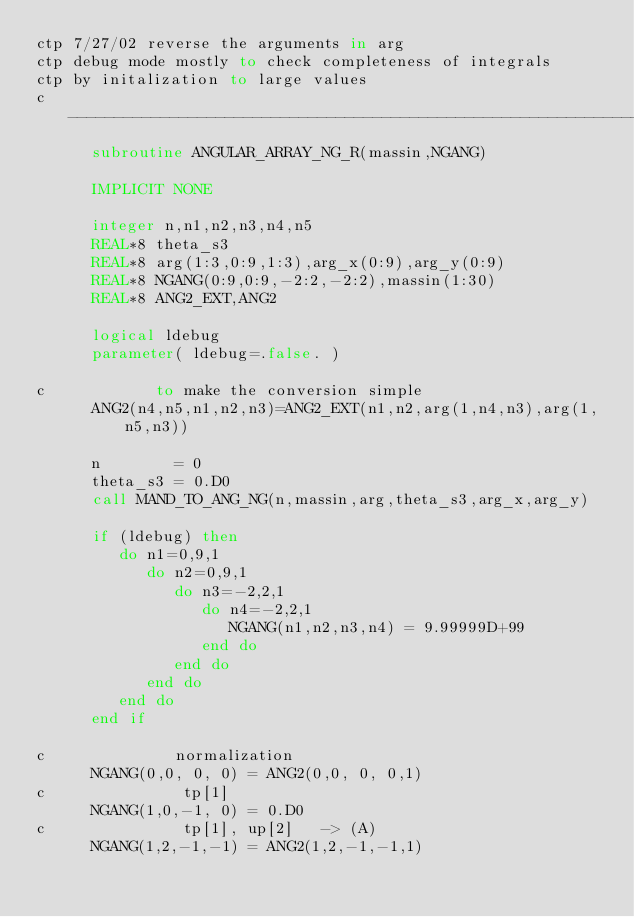<code> <loc_0><loc_0><loc_500><loc_500><_FORTRAN_>ctp 7/27/02 reverse the arguments in arg
ctp debug mode mostly to check completeness of integrals 
ctp by initalization to large values 
c ----------------------------------------------------------------------
      subroutine ANGULAR_ARRAY_NG_R(massin,NGANG)

      IMPLICIT NONE

      integer n,n1,n2,n3,n4,n5
      REAL*8 theta_s3
      REAL*8 arg(1:3,0:9,1:3),arg_x(0:9),arg_y(0:9)
      REAL*8 NGANG(0:9,0:9,-2:2,-2:2),massin(1:30)
      REAL*8 ANG2_EXT,ANG2

      logical ldebug 
      parameter( ldebug=.false. )
           
c            to make the conversion simple  
      ANG2(n4,n5,n1,n2,n3)=ANG2_EXT(n1,n2,arg(1,n4,n3),arg(1,n5,n3))
     
      n        = 0
      theta_s3 = 0.D0
      call MAND_TO_ANG_NG(n,massin,arg,theta_s3,arg_x,arg_y)
      
      if (ldebug) then 
         do n1=0,9,1
            do n2=0,9,1
               do n3=-2,2,1
                  do n4=-2,2,1
                     NGANG(n1,n2,n3,n4) = 9.99999D+99
                  end do
               end do
            end do
         end do
      end if

c              normalization 
      NGANG(0,0, 0, 0) = ANG2(0,0, 0, 0,1)
c               tp[1]        
      NGANG(1,0,-1, 0) = 0.D0
c               tp[1], up[2]   -> (A)
      NGANG(1,2,-1,-1) = ANG2(1,2,-1,-1,1)</code> 